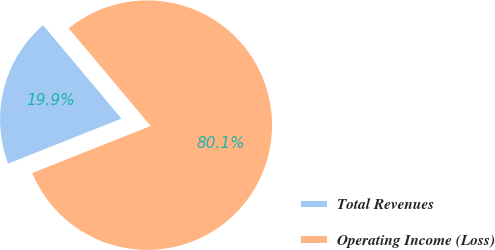<chart> <loc_0><loc_0><loc_500><loc_500><pie_chart><fcel>Total Revenues<fcel>Operating Income (Loss)<nl><fcel>19.91%<fcel>80.09%<nl></chart> 